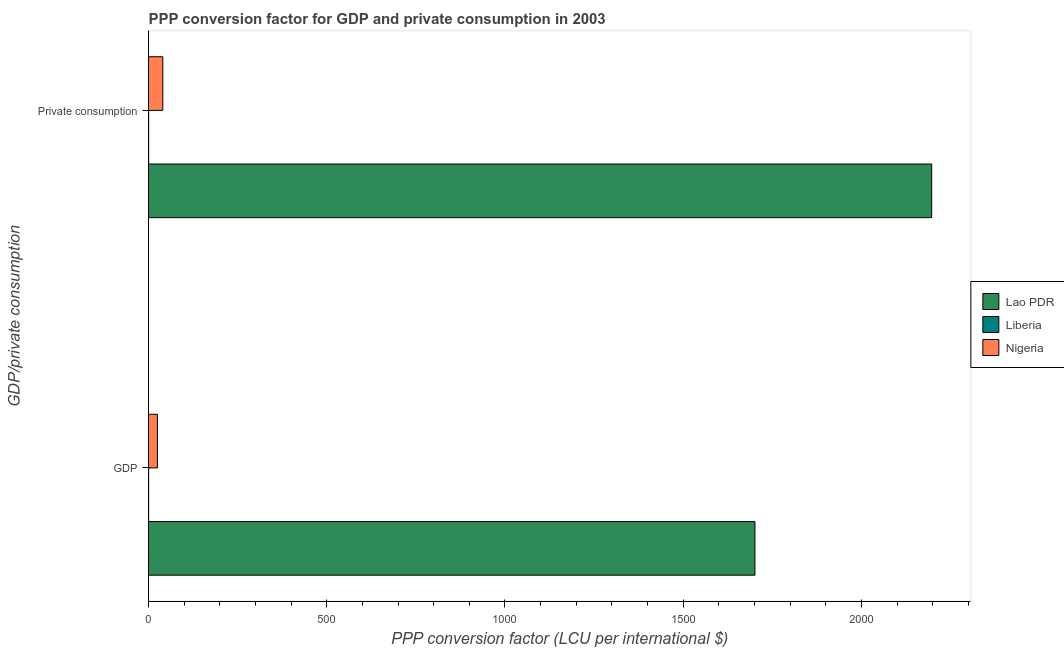How many different coloured bars are there?
Your response must be concise. 3. Are the number of bars per tick equal to the number of legend labels?
Provide a succinct answer. Yes. How many bars are there on the 2nd tick from the bottom?
Your answer should be compact. 3. What is the label of the 2nd group of bars from the top?
Your answer should be compact. GDP. What is the ppp conversion factor for gdp in Lao PDR?
Give a very brief answer. 1701.37. Across all countries, what is the maximum ppp conversion factor for gdp?
Give a very brief answer. 1701.37. Across all countries, what is the minimum ppp conversion factor for gdp?
Your response must be concise. 0.27. In which country was the ppp conversion factor for private consumption maximum?
Your response must be concise. Lao PDR. In which country was the ppp conversion factor for private consumption minimum?
Make the answer very short. Liberia. What is the total ppp conversion factor for private consumption in the graph?
Ensure brevity in your answer.  2237.62. What is the difference between the ppp conversion factor for gdp in Lao PDR and that in Liberia?
Make the answer very short. 1701.1. What is the difference between the ppp conversion factor for private consumption in Liberia and the ppp conversion factor for gdp in Lao PDR?
Provide a short and direct response. -1701.04. What is the average ppp conversion factor for gdp per country?
Give a very brief answer. 575.55. What is the difference between the ppp conversion factor for private consumption and ppp conversion factor for gdp in Nigeria?
Your answer should be very brief. 15.11. In how many countries, is the ppp conversion factor for private consumption greater than 2100 LCU?
Offer a terse response. 1. What is the ratio of the ppp conversion factor for gdp in Nigeria to that in Lao PDR?
Provide a short and direct response. 0.01. What does the 2nd bar from the top in  Private consumption represents?
Your response must be concise. Liberia. What does the 2nd bar from the bottom in  Private consumption represents?
Offer a very short reply. Liberia. How many bars are there?
Your answer should be compact. 6. What is the difference between two consecutive major ticks on the X-axis?
Make the answer very short. 500. Are the values on the major ticks of X-axis written in scientific E-notation?
Give a very brief answer. No. Does the graph contain any zero values?
Your answer should be very brief. No. Where does the legend appear in the graph?
Provide a short and direct response. Center right. What is the title of the graph?
Provide a succinct answer. PPP conversion factor for GDP and private consumption in 2003. What is the label or title of the X-axis?
Make the answer very short. PPP conversion factor (LCU per international $). What is the label or title of the Y-axis?
Your answer should be very brief. GDP/private consumption. What is the PPP conversion factor (LCU per international $) of Lao PDR in GDP?
Ensure brevity in your answer.  1701.37. What is the PPP conversion factor (LCU per international $) in Liberia in GDP?
Your answer should be compact. 0.27. What is the PPP conversion factor (LCU per international $) of Nigeria in GDP?
Offer a very short reply. 24.99. What is the PPP conversion factor (LCU per international $) in Lao PDR in  Private consumption?
Make the answer very short. 2197.19. What is the PPP conversion factor (LCU per international $) of Liberia in  Private consumption?
Offer a terse response. 0.33. What is the PPP conversion factor (LCU per international $) in Nigeria in  Private consumption?
Keep it short and to the point. 40.1. Across all GDP/private consumption, what is the maximum PPP conversion factor (LCU per international $) in Lao PDR?
Your response must be concise. 2197.19. Across all GDP/private consumption, what is the maximum PPP conversion factor (LCU per international $) of Liberia?
Your answer should be very brief. 0.33. Across all GDP/private consumption, what is the maximum PPP conversion factor (LCU per international $) of Nigeria?
Your answer should be very brief. 40.1. Across all GDP/private consumption, what is the minimum PPP conversion factor (LCU per international $) in Lao PDR?
Ensure brevity in your answer.  1701.37. Across all GDP/private consumption, what is the minimum PPP conversion factor (LCU per international $) in Liberia?
Your response must be concise. 0.27. Across all GDP/private consumption, what is the minimum PPP conversion factor (LCU per international $) in Nigeria?
Keep it short and to the point. 24.99. What is the total PPP conversion factor (LCU per international $) of Lao PDR in the graph?
Provide a succinct answer. 3898.56. What is the total PPP conversion factor (LCU per international $) of Liberia in the graph?
Your response must be concise. 0.61. What is the total PPP conversion factor (LCU per international $) in Nigeria in the graph?
Provide a short and direct response. 65.09. What is the difference between the PPP conversion factor (LCU per international $) of Lao PDR in GDP and that in  Private consumption?
Make the answer very short. -495.81. What is the difference between the PPP conversion factor (LCU per international $) in Liberia in GDP and that in  Private consumption?
Your answer should be compact. -0.06. What is the difference between the PPP conversion factor (LCU per international $) of Nigeria in GDP and that in  Private consumption?
Your answer should be compact. -15.11. What is the difference between the PPP conversion factor (LCU per international $) of Lao PDR in GDP and the PPP conversion factor (LCU per international $) of Liberia in  Private consumption?
Your answer should be very brief. 1701.04. What is the difference between the PPP conversion factor (LCU per international $) in Lao PDR in GDP and the PPP conversion factor (LCU per international $) in Nigeria in  Private consumption?
Your response must be concise. 1661.28. What is the difference between the PPP conversion factor (LCU per international $) of Liberia in GDP and the PPP conversion factor (LCU per international $) of Nigeria in  Private consumption?
Offer a very short reply. -39.82. What is the average PPP conversion factor (LCU per international $) of Lao PDR per GDP/private consumption?
Make the answer very short. 1949.28. What is the average PPP conversion factor (LCU per international $) of Liberia per GDP/private consumption?
Your response must be concise. 0.3. What is the average PPP conversion factor (LCU per international $) of Nigeria per GDP/private consumption?
Provide a short and direct response. 32.54. What is the difference between the PPP conversion factor (LCU per international $) of Lao PDR and PPP conversion factor (LCU per international $) of Liberia in GDP?
Give a very brief answer. 1701.1. What is the difference between the PPP conversion factor (LCU per international $) in Lao PDR and PPP conversion factor (LCU per international $) in Nigeria in GDP?
Your answer should be very brief. 1676.39. What is the difference between the PPP conversion factor (LCU per international $) of Liberia and PPP conversion factor (LCU per international $) of Nigeria in GDP?
Offer a terse response. -24.71. What is the difference between the PPP conversion factor (LCU per international $) in Lao PDR and PPP conversion factor (LCU per international $) in Liberia in  Private consumption?
Provide a succinct answer. 2196.86. What is the difference between the PPP conversion factor (LCU per international $) in Lao PDR and PPP conversion factor (LCU per international $) in Nigeria in  Private consumption?
Give a very brief answer. 2157.09. What is the difference between the PPP conversion factor (LCU per international $) of Liberia and PPP conversion factor (LCU per international $) of Nigeria in  Private consumption?
Keep it short and to the point. -39.77. What is the ratio of the PPP conversion factor (LCU per international $) of Lao PDR in GDP to that in  Private consumption?
Give a very brief answer. 0.77. What is the ratio of the PPP conversion factor (LCU per international $) of Liberia in GDP to that in  Private consumption?
Keep it short and to the point. 0.83. What is the ratio of the PPP conversion factor (LCU per international $) in Nigeria in GDP to that in  Private consumption?
Provide a short and direct response. 0.62. What is the difference between the highest and the second highest PPP conversion factor (LCU per international $) of Lao PDR?
Your response must be concise. 495.81. What is the difference between the highest and the second highest PPP conversion factor (LCU per international $) in Liberia?
Your answer should be compact. 0.06. What is the difference between the highest and the second highest PPP conversion factor (LCU per international $) of Nigeria?
Provide a short and direct response. 15.11. What is the difference between the highest and the lowest PPP conversion factor (LCU per international $) in Lao PDR?
Give a very brief answer. 495.81. What is the difference between the highest and the lowest PPP conversion factor (LCU per international $) of Liberia?
Provide a short and direct response. 0.06. What is the difference between the highest and the lowest PPP conversion factor (LCU per international $) of Nigeria?
Provide a short and direct response. 15.11. 